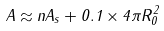<formula> <loc_0><loc_0><loc_500><loc_500>A \approx n A _ { s } + 0 . 1 \times 4 \pi R _ { 0 } ^ { 2 }</formula> 